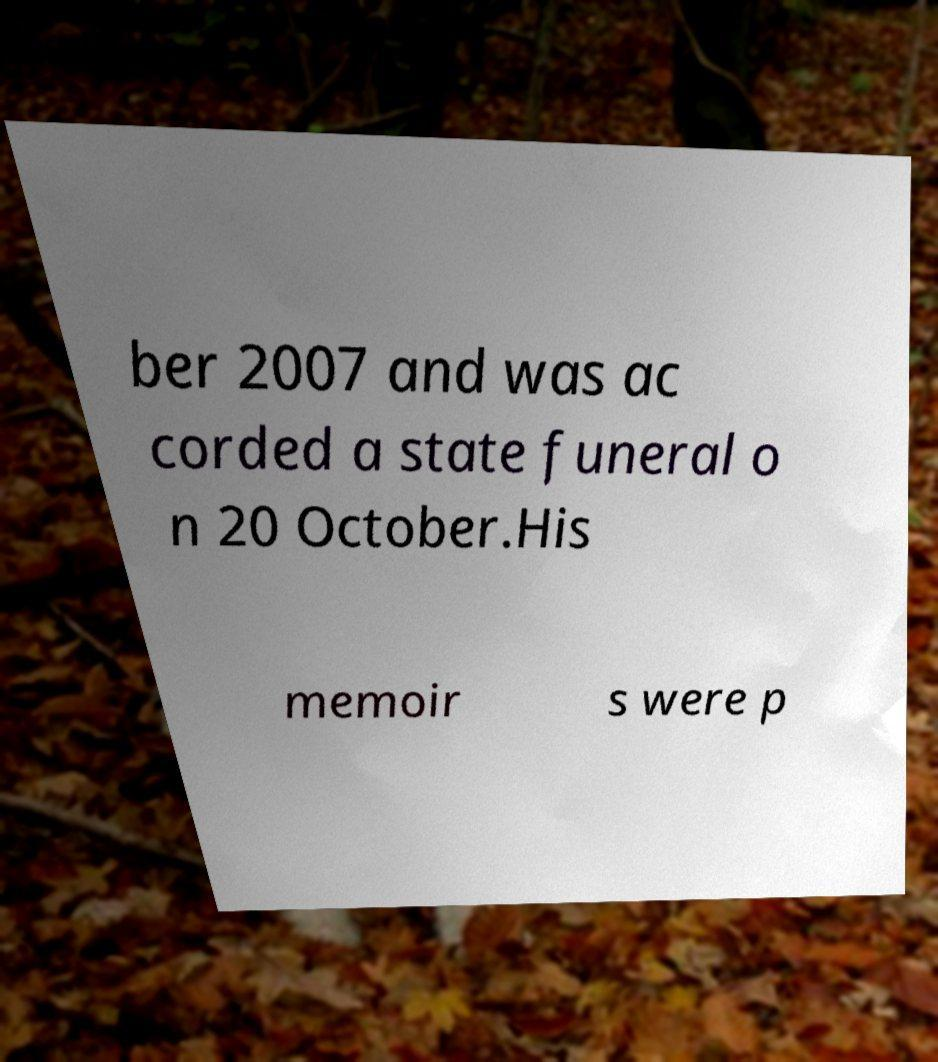What messages or text are displayed in this image? I need them in a readable, typed format. ber 2007 and was ac corded a state funeral o n 20 October.His memoir s were p 